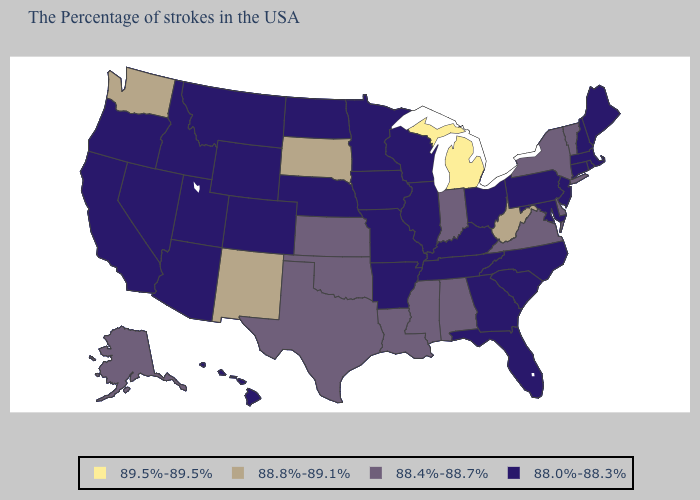Name the states that have a value in the range 88.8%-89.1%?
Write a very short answer. West Virginia, South Dakota, New Mexico, Washington. Does Vermont have the highest value in the Northeast?
Keep it brief. Yes. Is the legend a continuous bar?
Quick response, please. No. Does South Carolina have the highest value in the South?
Answer briefly. No. What is the value of North Carolina?
Quick response, please. 88.0%-88.3%. Does Vermont have the lowest value in the Northeast?
Give a very brief answer. No. Name the states that have a value in the range 89.5%-89.5%?
Give a very brief answer. Michigan. Does Maryland have the same value as Louisiana?
Concise answer only. No. Name the states that have a value in the range 88.8%-89.1%?
Quick response, please. West Virginia, South Dakota, New Mexico, Washington. Does the first symbol in the legend represent the smallest category?
Write a very short answer. No. What is the value of New York?
Short answer required. 88.4%-88.7%. Among the states that border Utah , which have the highest value?
Write a very short answer. New Mexico. What is the highest value in the Northeast ?
Short answer required. 88.4%-88.7%. Among the states that border Vermont , which have the lowest value?
Write a very short answer. Massachusetts, New Hampshire. How many symbols are there in the legend?
Quick response, please. 4. 